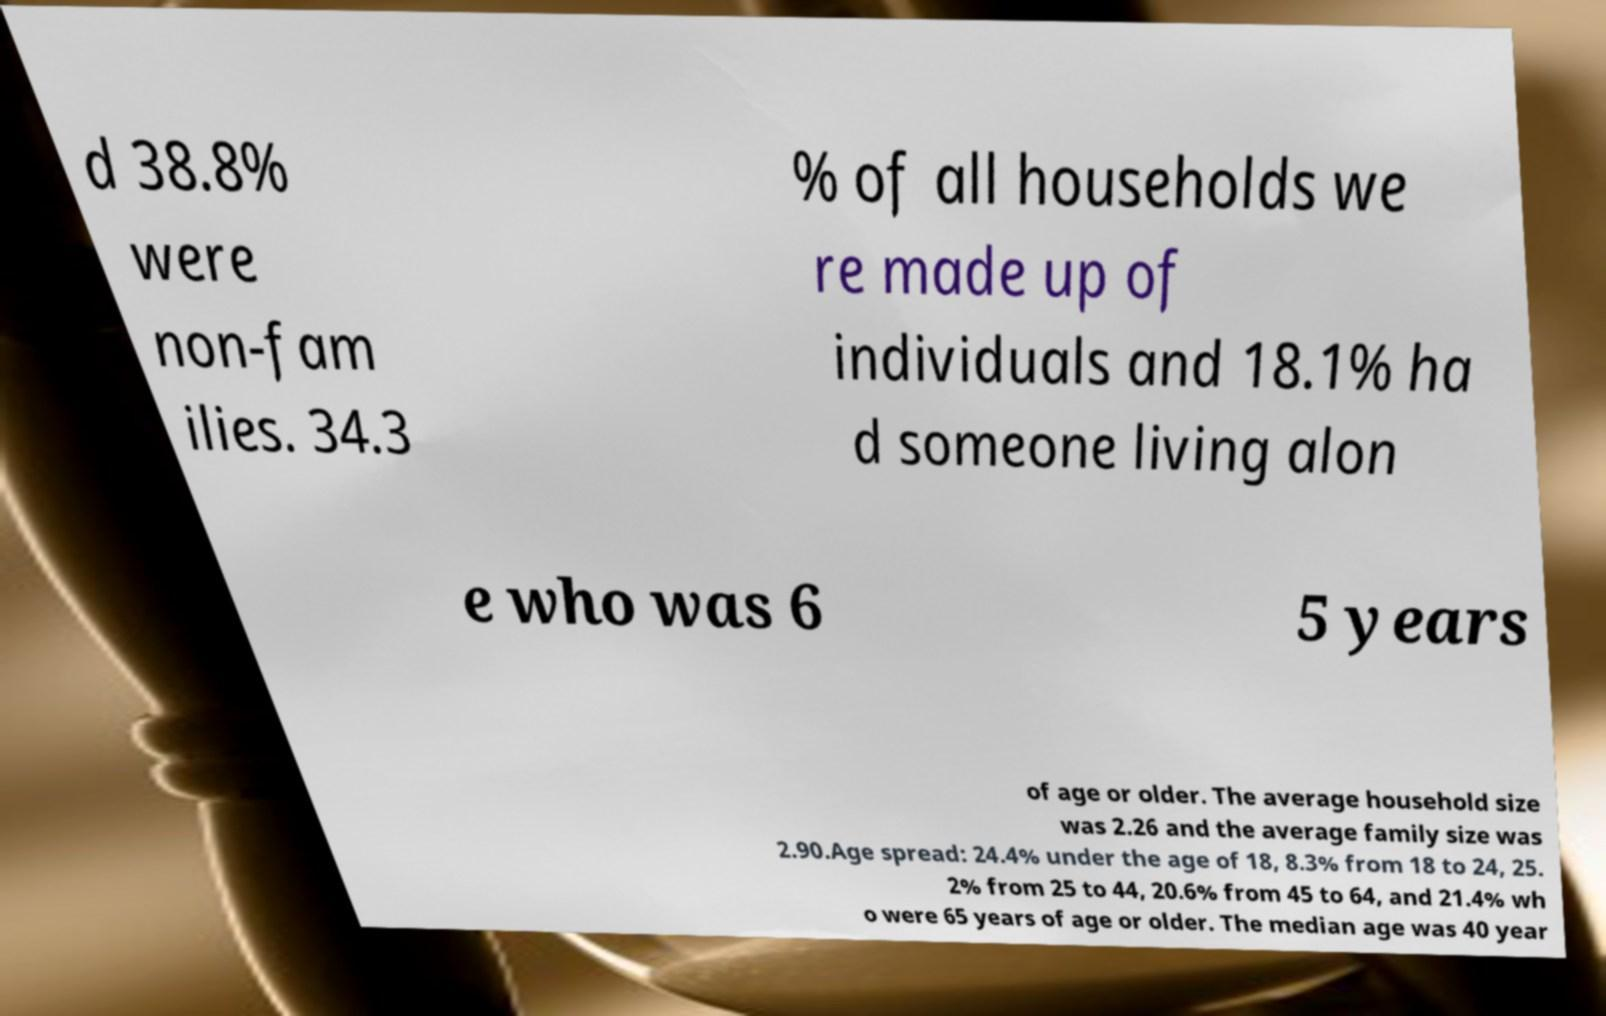Could you extract and type out the text from this image? d 38.8% were non-fam ilies. 34.3 % of all households we re made up of individuals and 18.1% ha d someone living alon e who was 6 5 years of age or older. The average household size was 2.26 and the average family size was 2.90.Age spread: 24.4% under the age of 18, 8.3% from 18 to 24, 25. 2% from 25 to 44, 20.6% from 45 to 64, and 21.4% wh o were 65 years of age or older. The median age was 40 year 